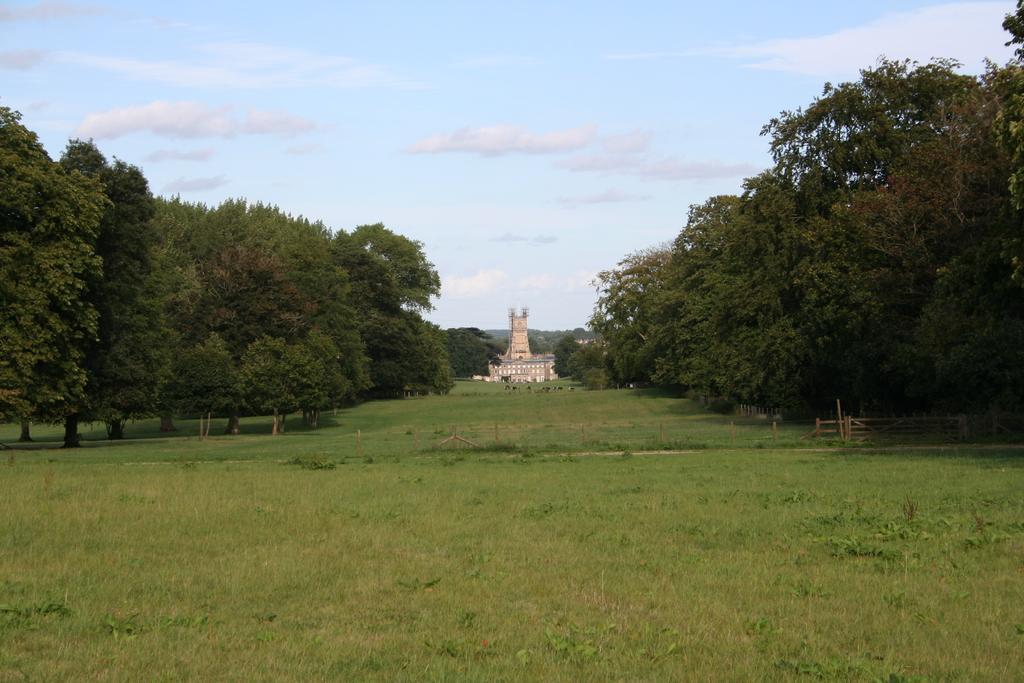Please provide a concise description of this image. In this picture I can see a building and few trees and I can see grass on the ground and a blue cloudy sky. 